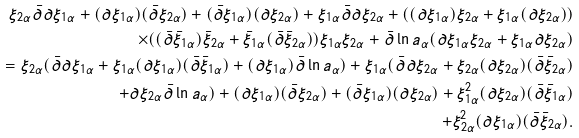<formula> <loc_0><loc_0><loc_500><loc_500>\xi _ { 2 \alpha } \bar { \partial } \partial \xi _ { 1 \alpha } + ( \partial \xi _ { 1 \alpha } ) ( \bar { \partial } \xi _ { 2 \alpha } ) + ( \bar { \partial } \xi _ { 1 \alpha } ) ( \partial \xi _ { 2 \alpha } ) + \xi _ { 1 \alpha } \bar { \partial } \partial \xi _ { 2 \alpha } + ( ( \partial \xi _ { 1 \alpha } ) \xi _ { 2 \alpha } + \xi _ { 1 \alpha } ( \partial \xi _ { 2 \alpha } ) ) \\ \times ( ( \bar { \partial } \bar { \xi } _ { 1 \alpha } ) \bar { \xi } _ { 2 \alpha } + \bar { \xi } _ { 1 \alpha } ( \bar { \partial } \bar { \xi } _ { 2 \alpha } ) ) \xi _ { 1 \alpha } \xi _ { 2 \alpha } + \bar { \partial } \ln a _ { \alpha } ( \partial \xi _ { 1 \alpha } \xi _ { 2 \alpha } + \xi _ { 1 \alpha } \partial \xi _ { 2 \alpha } ) \\ = \xi _ { 2 \alpha } ( \bar { \partial } \partial \xi _ { 1 \alpha } + \xi _ { 1 \alpha } ( \partial \xi _ { 1 \alpha } ) ( \bar { \partial } \bar { \xi } _ { 1 \alpha } ) + ( \partial \xi _ { 1 \alpha } ) \bar { \partial } \ln a _ { \alpha } ) + \xi _ { 1 \alpha } ( \bar { \partial } \partial \xi _ { 2 \alpha } + \xi _ { 2 \alpha } ( \partial \xi _ { 2 \alpha } ) ( \bar { \partial } \bar { \xi } _ { 2 \alpha } ) \\ + \partial \xi _ { 2 \alpha } \bar { \partial } \ln a _ { \alpha } ) + ( \partial \xi _ { 1 \alpha } ) ( \bar { \partial } \xi _ { 2 \alpha } ) + ( \bar { \partial } \xi _ { 1 \alpha } ) ( \partial \xi _ { 2 \alpha } ) + \xi _ { 1 \alpha } ^ { 2 } ( \partial \xi _ { 2 \alpha } ) ( \bar { \partial } \bar { \xi } _ { 1 \alpha } ) \\ + \xi _ { 2 \alpha } ^ { 2 } ( \partial \xi _ { 1 \alpha } ) ( \bar { \partial } \bar { \xi } _ { 2 \alpha } ) .</formula> 